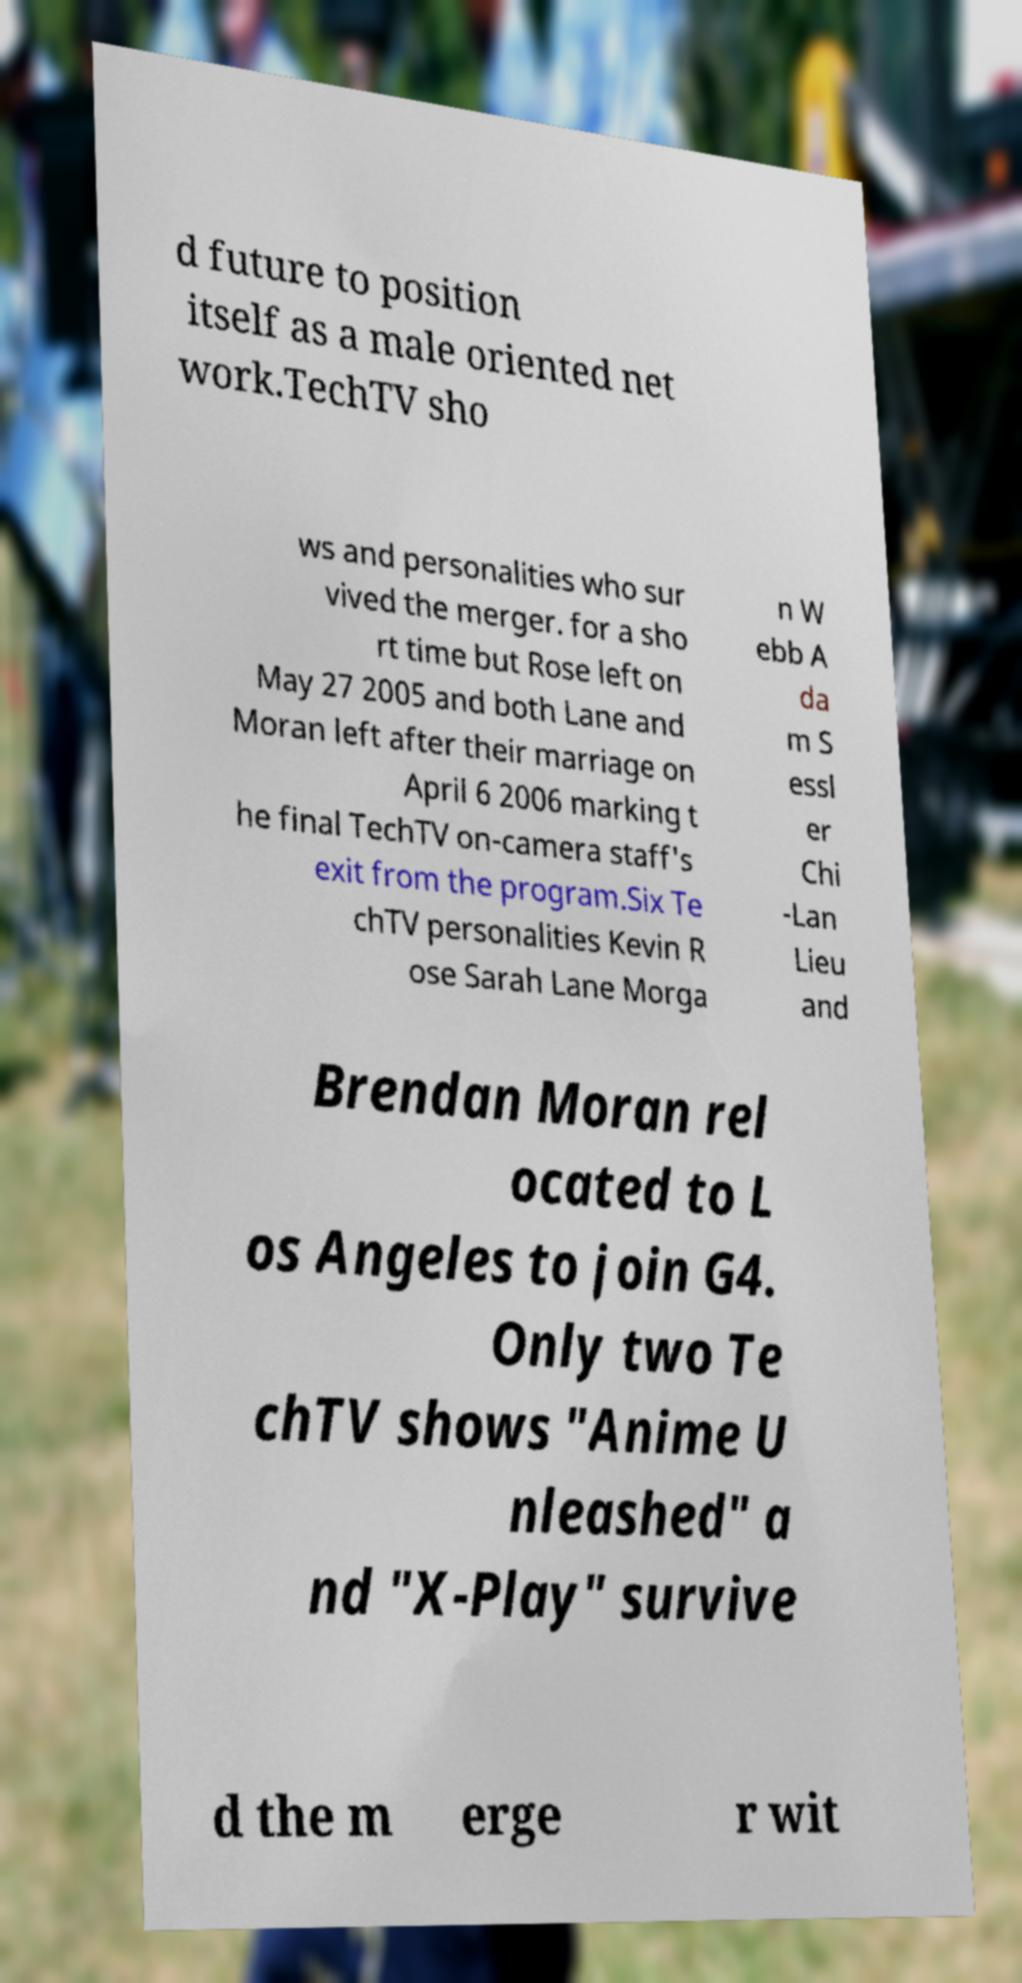For documentation purposes, I need the text within this image transcribed. Could you provide that? d future to position itself as a male oriented net work.TechTV sho ws and personalities who sur vived the merger. for a sho rt time but Rose left on May 27 2005 and both Lane and Moran left after their marriage on April 6 2006 marking t he final TechTV on-camera staff's exit from the program.Six Te chTV personalities Kevin R ose Sarah Lane Morga n W ebb A da m S essl er Chi -Lan Lieu and Brendan Moran rel ocated to L os Angeles to join G4. Only two Te chTV shows "Anime U nleashed" a nd "X-Play" survive d the m erge r wit 